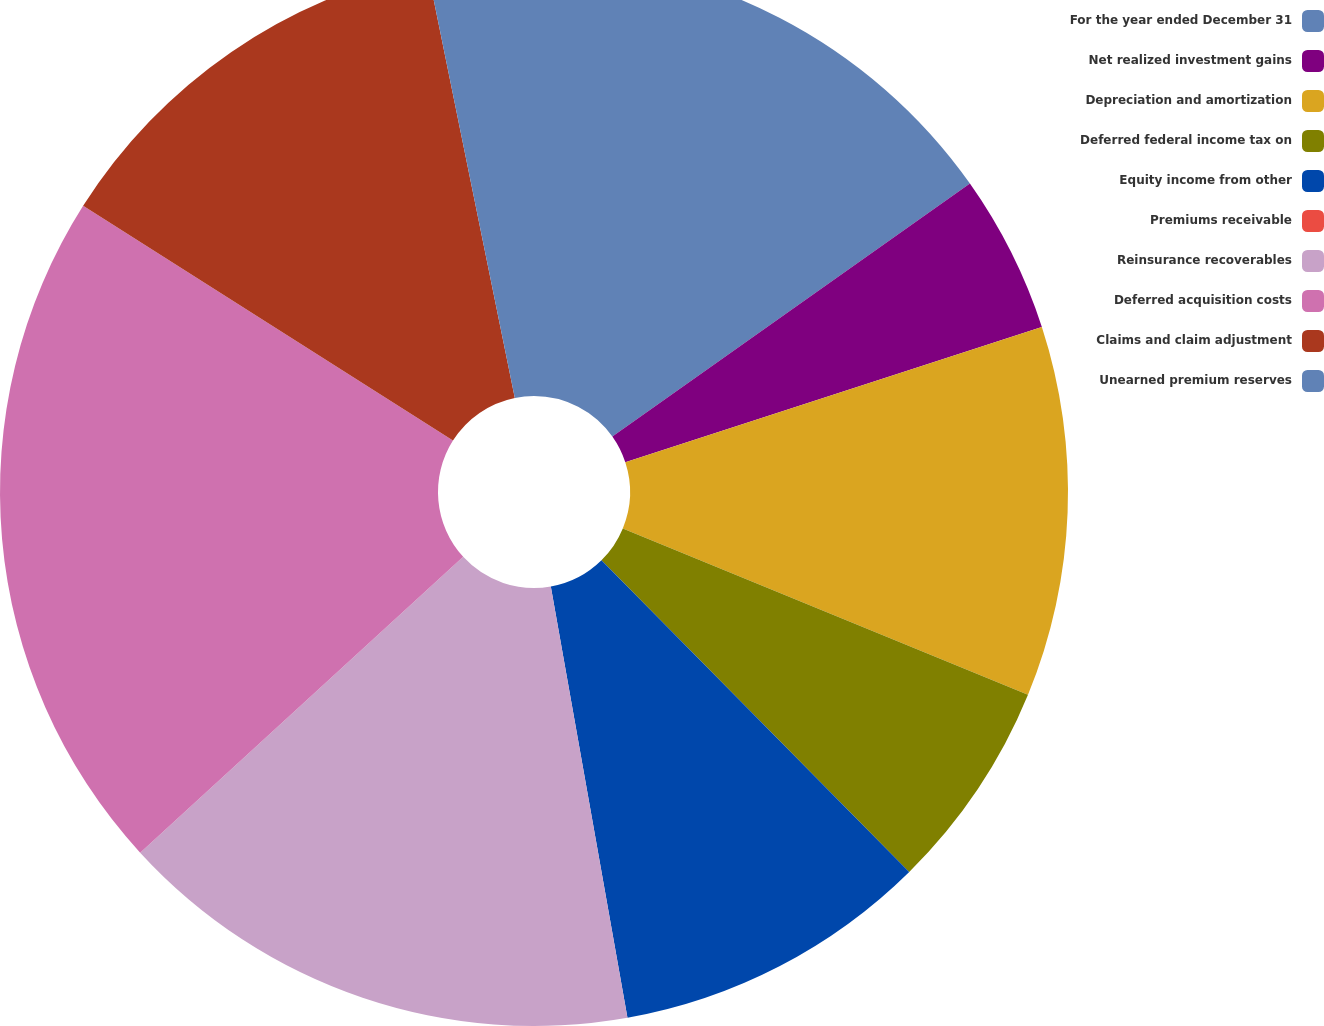Convert chart. <chart><loc_0><loc_0><loc_500><loc_500><pie_chart><fcel>For the year ended December 31<fcel>Net realized investment gains<fcel>Depreciation and amortization<fcel>Deferred federal income tax on<fcel>Equity income from other<fcel>Premiums receivable<fcel>Reinsurance recoverables<fcel>Deferred acquisition costs<fcel>Claims and claim adjustment<fcel>Unearned premium reserves<nl><fcel>15.2%<fcel>4.8%<fcel>11.2%<fcel>6.4%<fcel>9.6%<fcel>0.0%<fcel>16.0%<fcel>20.8%<fcel>12.8%<fcel>3.2%<nl></chart> 